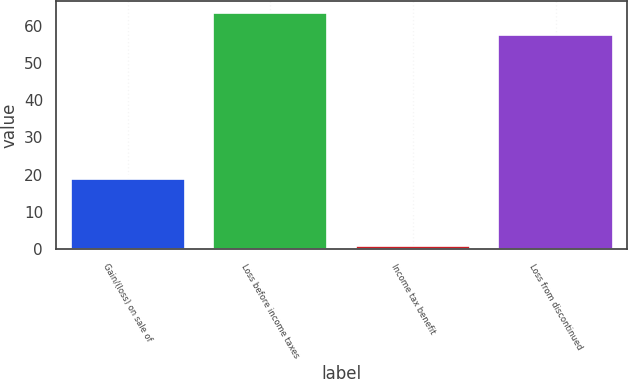Convert chart. <chart><loc_0><loc_0><loc_500><loc_500><bar_chart><fcel>Gain/(loss) on sale of<fcel>Loss before income taxes<fcel>Income tax benefit<fcel>Loss from discontinued<nl><fcel>18.7<fcel>63.36<fcel>0.8<fcel>57.6<nl></chart> 